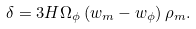<formula> <loc_0><loc_0><loc_500><loc_500>\delta = 3 H \Omega _ { \phi } \left ( w _ { m } - w _ { \phi } \right ) \rho _ { m } .</formula> 